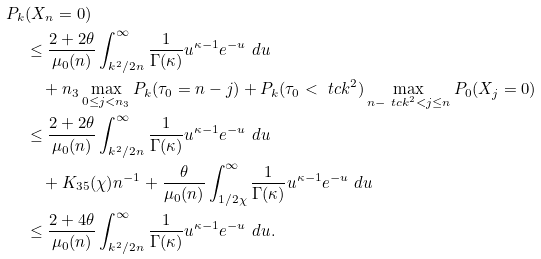Convert formula to latex. <formula><loc_0><loc_0><loc_500><loc_500>P _ { k } & ( X _ { n } = 0 ) \\ & \leq \frac { 2 + 2 \theta } { \mu _ { 0 } ( n ) } \int _ { k ^ { 2 } / 2 n } ^ { \infty } \frac { 1 } { \Gamma ( \kappa ) } u ^ { \kappa - 1 } e ^ { - u } \ d u \\ & \quad + n _ { 3 } \max _ { 0 \leq j < n _ { 3 } } P _ { k } ( \tau _ { 0 } = n - j ) + P _ { k } ( \tau _ { 0 } < \ t c k ^ { 2 } ) \max _ { n - \ t c k ^ { 2 } < j \leq n } P _ { 0 } ( X _ { j } = 0 ) \\ & \leq \frac { 2 + 2 \theta } { \mu _ { 0 } ( n ) } \int _ { k ^ { 2 } / 2 n } ^ { \infty } \frac { 1 } { \Gamma ( \kappa ) } u ^ { \kappa - 1 } e ^ { - u } \ d u \\ & \quad + K _ { 3 5 } ( \chi ) n ^ { - 1 } + \frac { \theta } { \mu _ { 0 } ( n ) } \int _ { 1 / 2 \chi } ^ { \infty } \frac { 1 } { \Gamma ( \kappa ) } u ^ { \kappa - 1 } e ^ { - u } \ d u \\ & \leq \frac { 2 + 4 \theta } { \mu _ { 0 } ( n ) } \int _ { k ^ { 2 } / 2 n } ^ { \infty } \frac { 1 } { \Gamma ( \kappa ) } u ^ { \kappa - 1 } e ^ { - u } \ d u .</formula> 